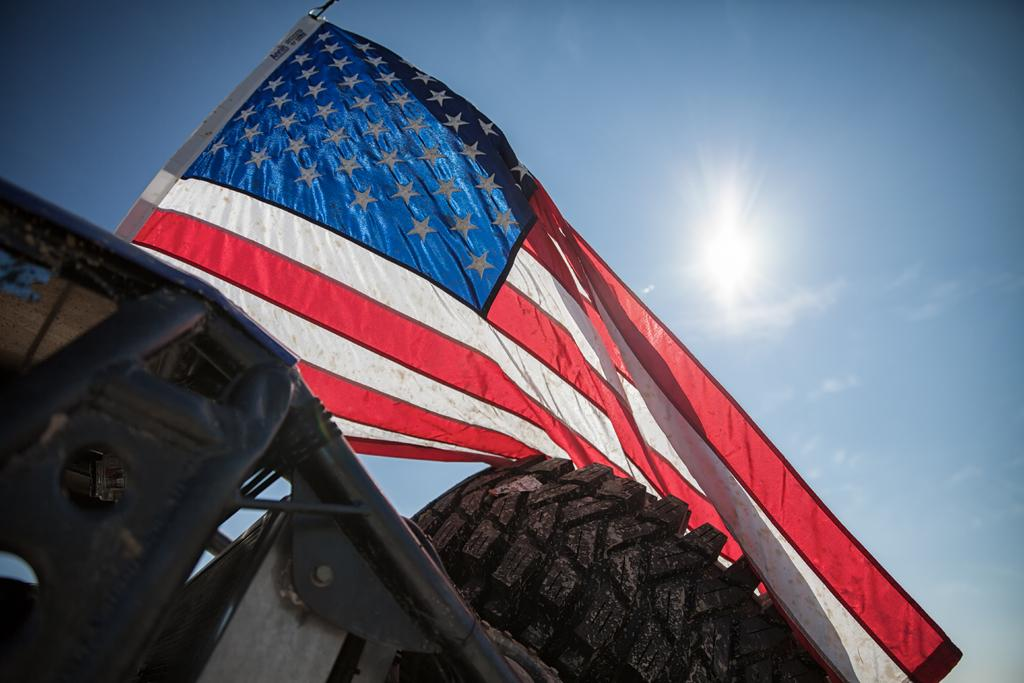What is the main subject in the image? There is a vehicle in the image. Are there any other objects or symbols present in the image? Yes, there is a flag in the image. What can be seen in the background of the image? The sky is visible in the background of the image. What type of zephyr can be seen coming from the vehicle in the image? There is no zephyr present in the image. 